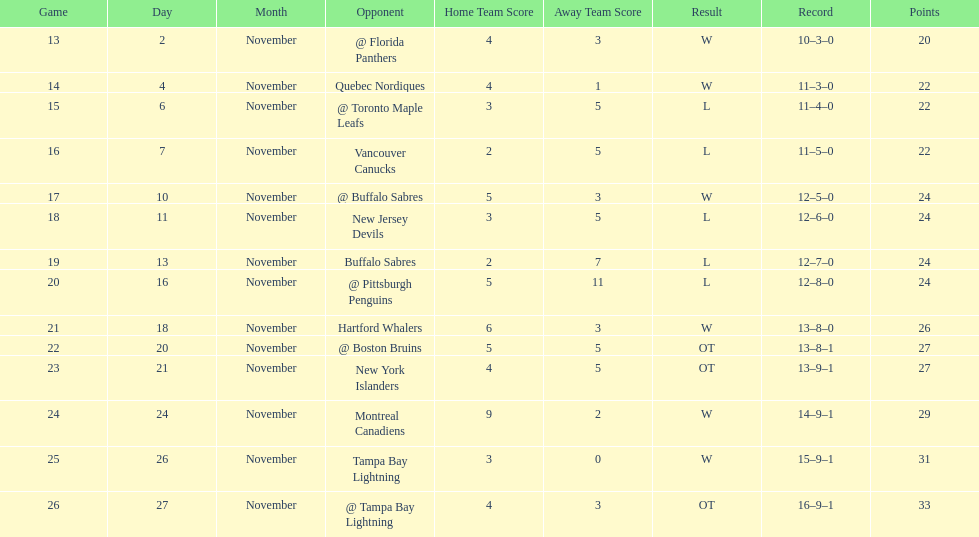Which was the only team in the atlantic division in the 1993-1994 season to acquire less points than the philadelphia flyers? Tampa Bay Lightning. 